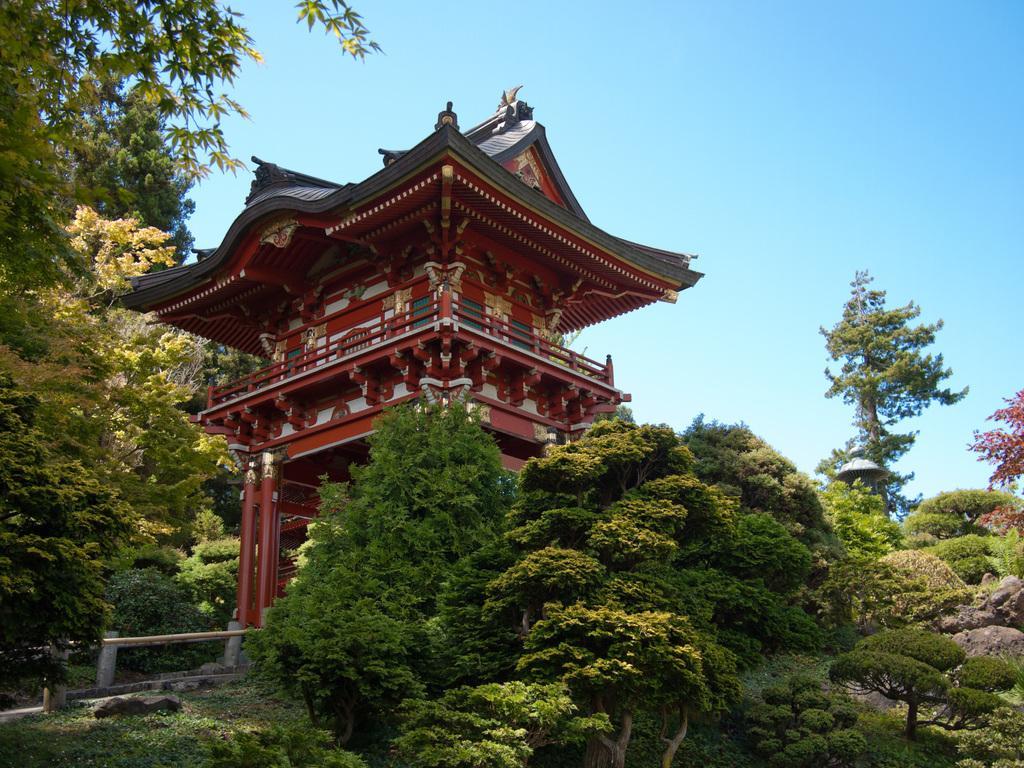In one or two sentences, can you explain what this image depicts? In this image there is a building surrounded by trees which are on the land having few rocks. Top of image there is sky. Left bottom there is fence. 